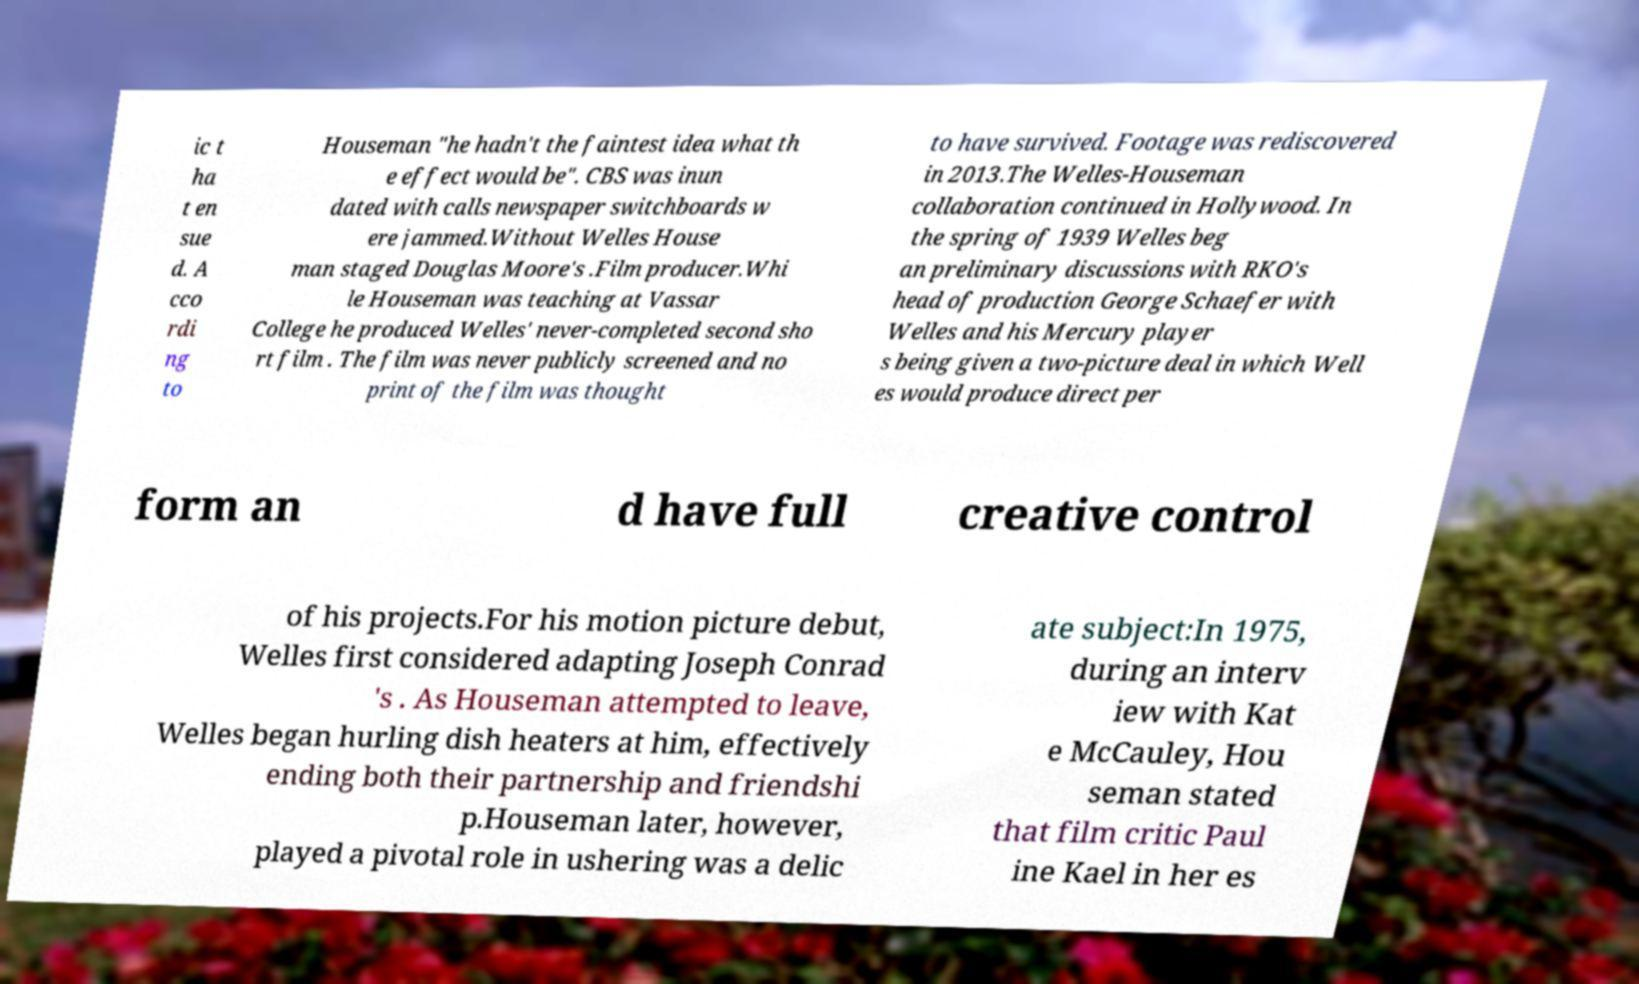Could you extract and type out the text from this image? ic t ha t en sue d. A cco rdi ng to Houseman "he hadn't the faintest idea what th e effect would be". CBS was inun dated with calls newspaper switchboards w ere jammed.Without Welles House man staged Douglas Moore's .Film producer.Whi le Houseman was teaching at Vassar College he produced Welles' never-completed second sho rt film . The film was never publicly screened and no print of the film was thought to have survived. Footage was rediscovered in 2013.The Welles-Houseman collaboration continued in Hollywood. In the spring of 1939 Welles beg an preliminary discussions with RKO's head of production George Schaefer with Welles and his Mercury player s being given a two-picture deal in which Well es would produce direct per form an d have full creative control of his projects.For his motion picture debut, Welles first considered adapting Joseph Conrad 's . As Houseman attempted to leave, Welles began hurling dish heaters at him, effectively ending both their partnership and friendshi p.Houseman later, however, played a pivotal role in ushering was a delic ate subject:In 1975, during an interv iew with Kat e McCauley, Hou seman stated that film critic Paul ine Kael in her es 